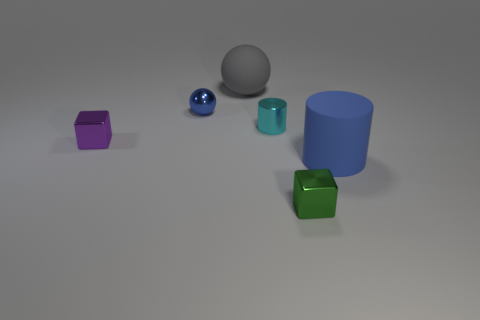Add 3 cyan metallic cylinders. How many objects exist? 9 Subtract all blocks. How many objects are left? 4 Add 5 small blue balls. How many small blue balls are left? 6 Add 5 big blue objects. How many big blue objects exist? 6 Subtract 0 cyan cubes. How many objects are left? 6 Subtract all cubes. Subtract all gray objects. How many objects are left? 3 